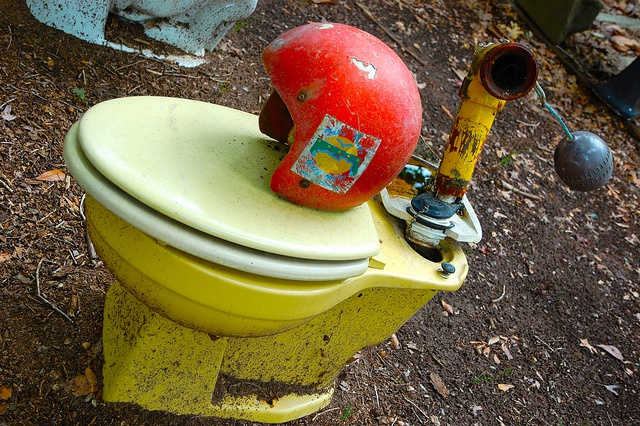Describe the objects in this image and their specific colors. I can see toilet in black, olive, beige, and khaki tones and toilet in black, teal, gray, and darkgray tones in this image. 